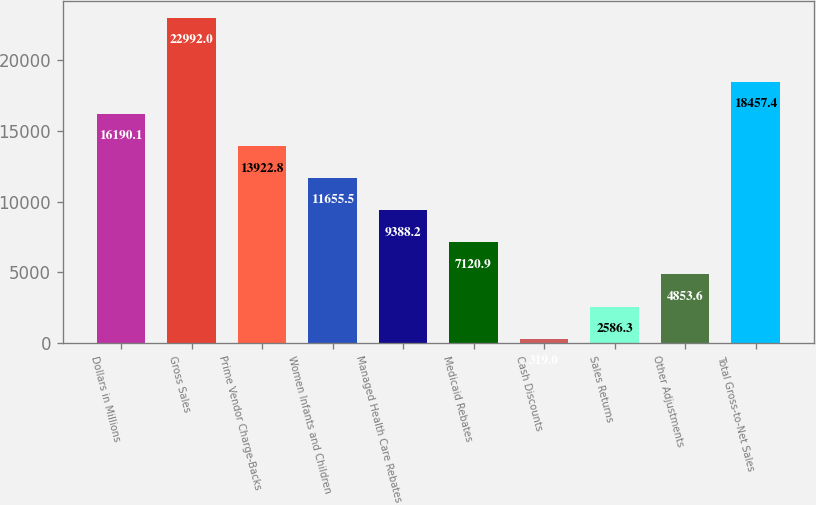Convert chart to OTSL. <chart><loc_0><loc_0><loc_500><loc_500><bar_chart><fcel>Dollars in Millions<fcel>Gross Sales<fcel>Prime Vendor Charge-Backs<fcel>Women Infants and Children<fcel>Managed Health Care Rebates<fcel>Medicaid Rebates<fcel>Cash Discounts<fcel>Sales Returns<fcel>Other Adjustments<fcel>Total Gross-to-Net Sales<nl><fcel>16190.1<fcel>22992<fcel>13922.8<fcel>11655.5<fcel>9388.2<fcel>7120.9<fcel>319<fcel>2586.3<fcel>4853.6<fcel>18457.4<nl></chart> 